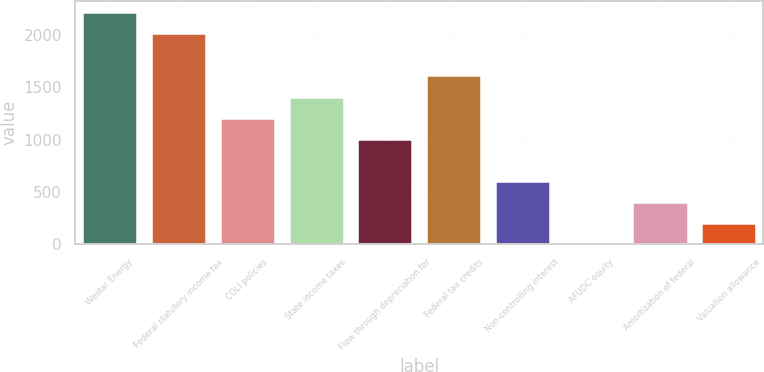Convert chart. <chart><loc_0><loc_0><loc_500><loc_500><bar_chart><fcel>Westar Energy<fcel>Federal statutory income tax<fcel>COLI policies<fcel>State income taxes<fcel>Flow through depreciation for<fcel>Federal tax credits<fcel>Non-controlling interest<fcel>AFUDC equity<fcel>Amortization of federal<fcel>Valuation allowance<nl><fcel>2218.68<fcel>2017<fcel>1210.28<fcel>1411.96<fcel>1008.6<fcel>1613.64<fcel>605.24<fcel>0.2<fcel>403.56<fcel>201.88<nl></chart> 